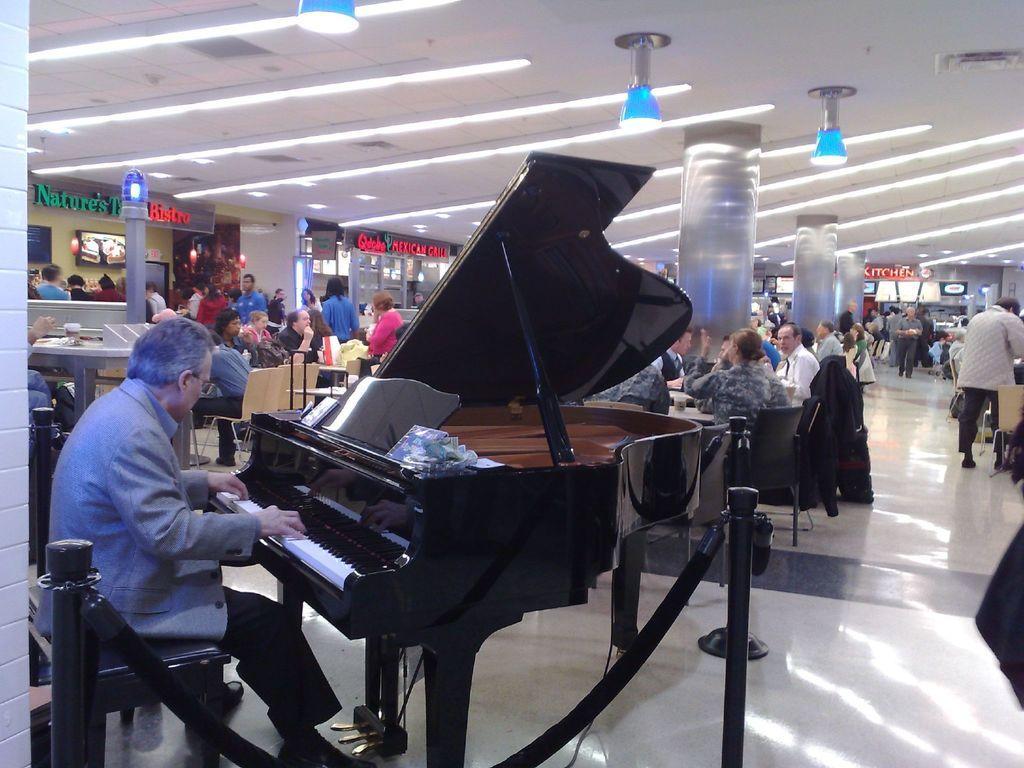How would you summarize this image in a sentence or two? This picture shows a man Seated on the chair and playing piano and we see few people seated and few are standing. 